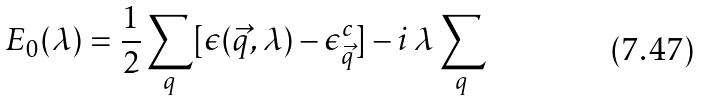Convert formula to latex. <formula><loc_0><loc_0><loc_500><loc_500>E _ { 0 } ( \lambda ) = \frac { 1 } { 2 } \sum _ { q } [ \epsilon ( \vec { q } , \lambda ) - \epsilon _ { \vec { q } } ^ { c } ] - i \, \lambda \sum _ { q }</formula> 